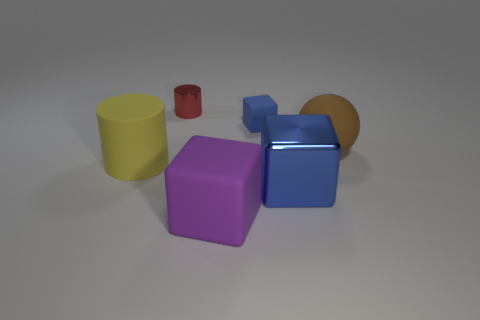What might be the purpose of arranging these objects in this manner? The arrangement of the objects might be for a display or to study the interplay of colors, materials, and shadows. It creates a visually pleasing composition that highlights the diversity in shapes and colors. Could this be part of a larger set, perhaps for educational purposes? It's certainly possible. These objects could be part of a set designed to teach concepts such as geometry, color theory, or even photography lighting techniques. The simplicity and clarity of the shapes make them ideal for instructional use. 